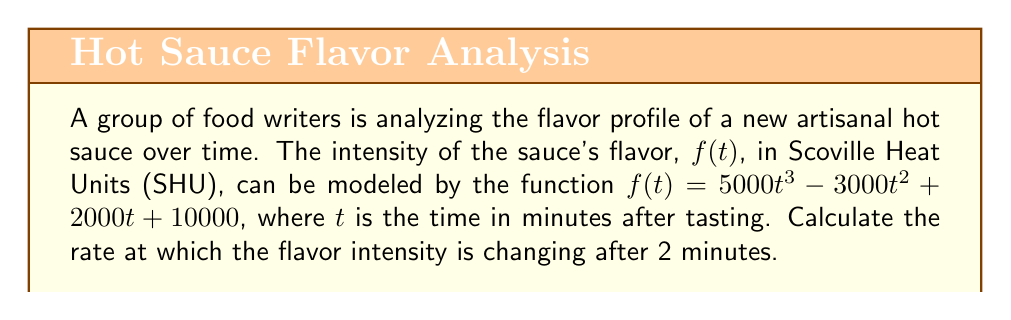Give your solution to this math problem. To find the rate of change in flavor intensity at a specific time, we need to calculate the derivative of the function $f(t)$ and then evaluate it at $t=2$.

Step 1: Calculate the derivative of $f(t)$.
$$f(t) = 5000t^3 - 3000t^2 + 2000t + 10000$$
$$f'(t) = 15000t^2 - 6000t + 2000$$

Step 2: Evaluate $f'(t)$ at $t=2$.
$$f'(2) = 15000(2)^2 - 6000(2) + 2000$$
$$f'(2) = 15000(4) - 12000 + 2000$$
$$f'(2) = 60000 - 12000 + 2000$$
$$f'(2) = 50000$$

The rate of change is measured in SHU per minute, so our final answer is 50,000 SHU/min.
Answer: 50,000 SHU/min 